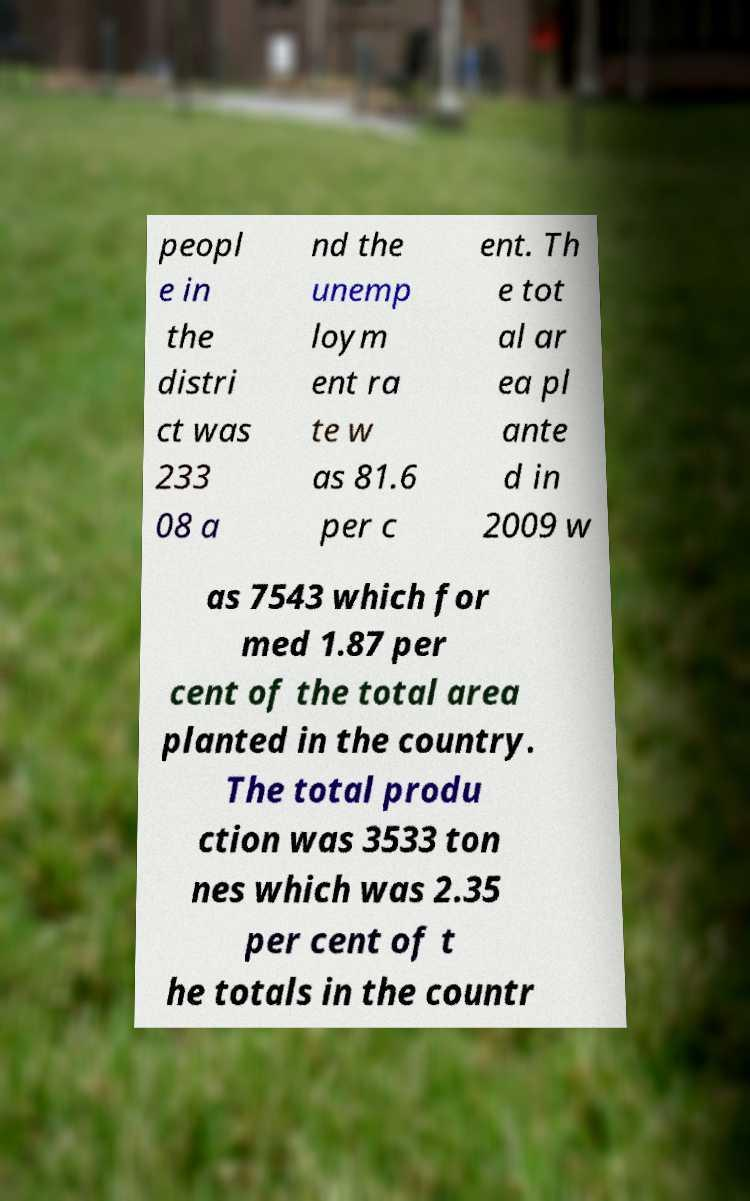Could you assist in decoding the text presented in this image and type it out clearly? peopl e in the distri ct was 233 08 a nd the unemp loym ent ra te w as 81.6 per c ent. Th e tot al ar ea pl ante d in 2009 w as 7543 which for med 1.87 per cent of the total area planted in the country. The total produ ction was 3533 ton nes which was 2.35 per cent of t he totals in the countr 